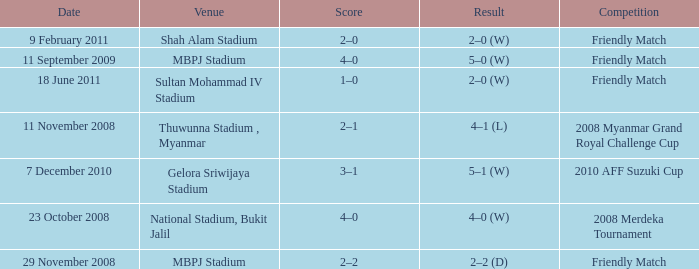What Competition in Shah Alam Stadium have a Result of 2–0 (w)? Friendly Match. 